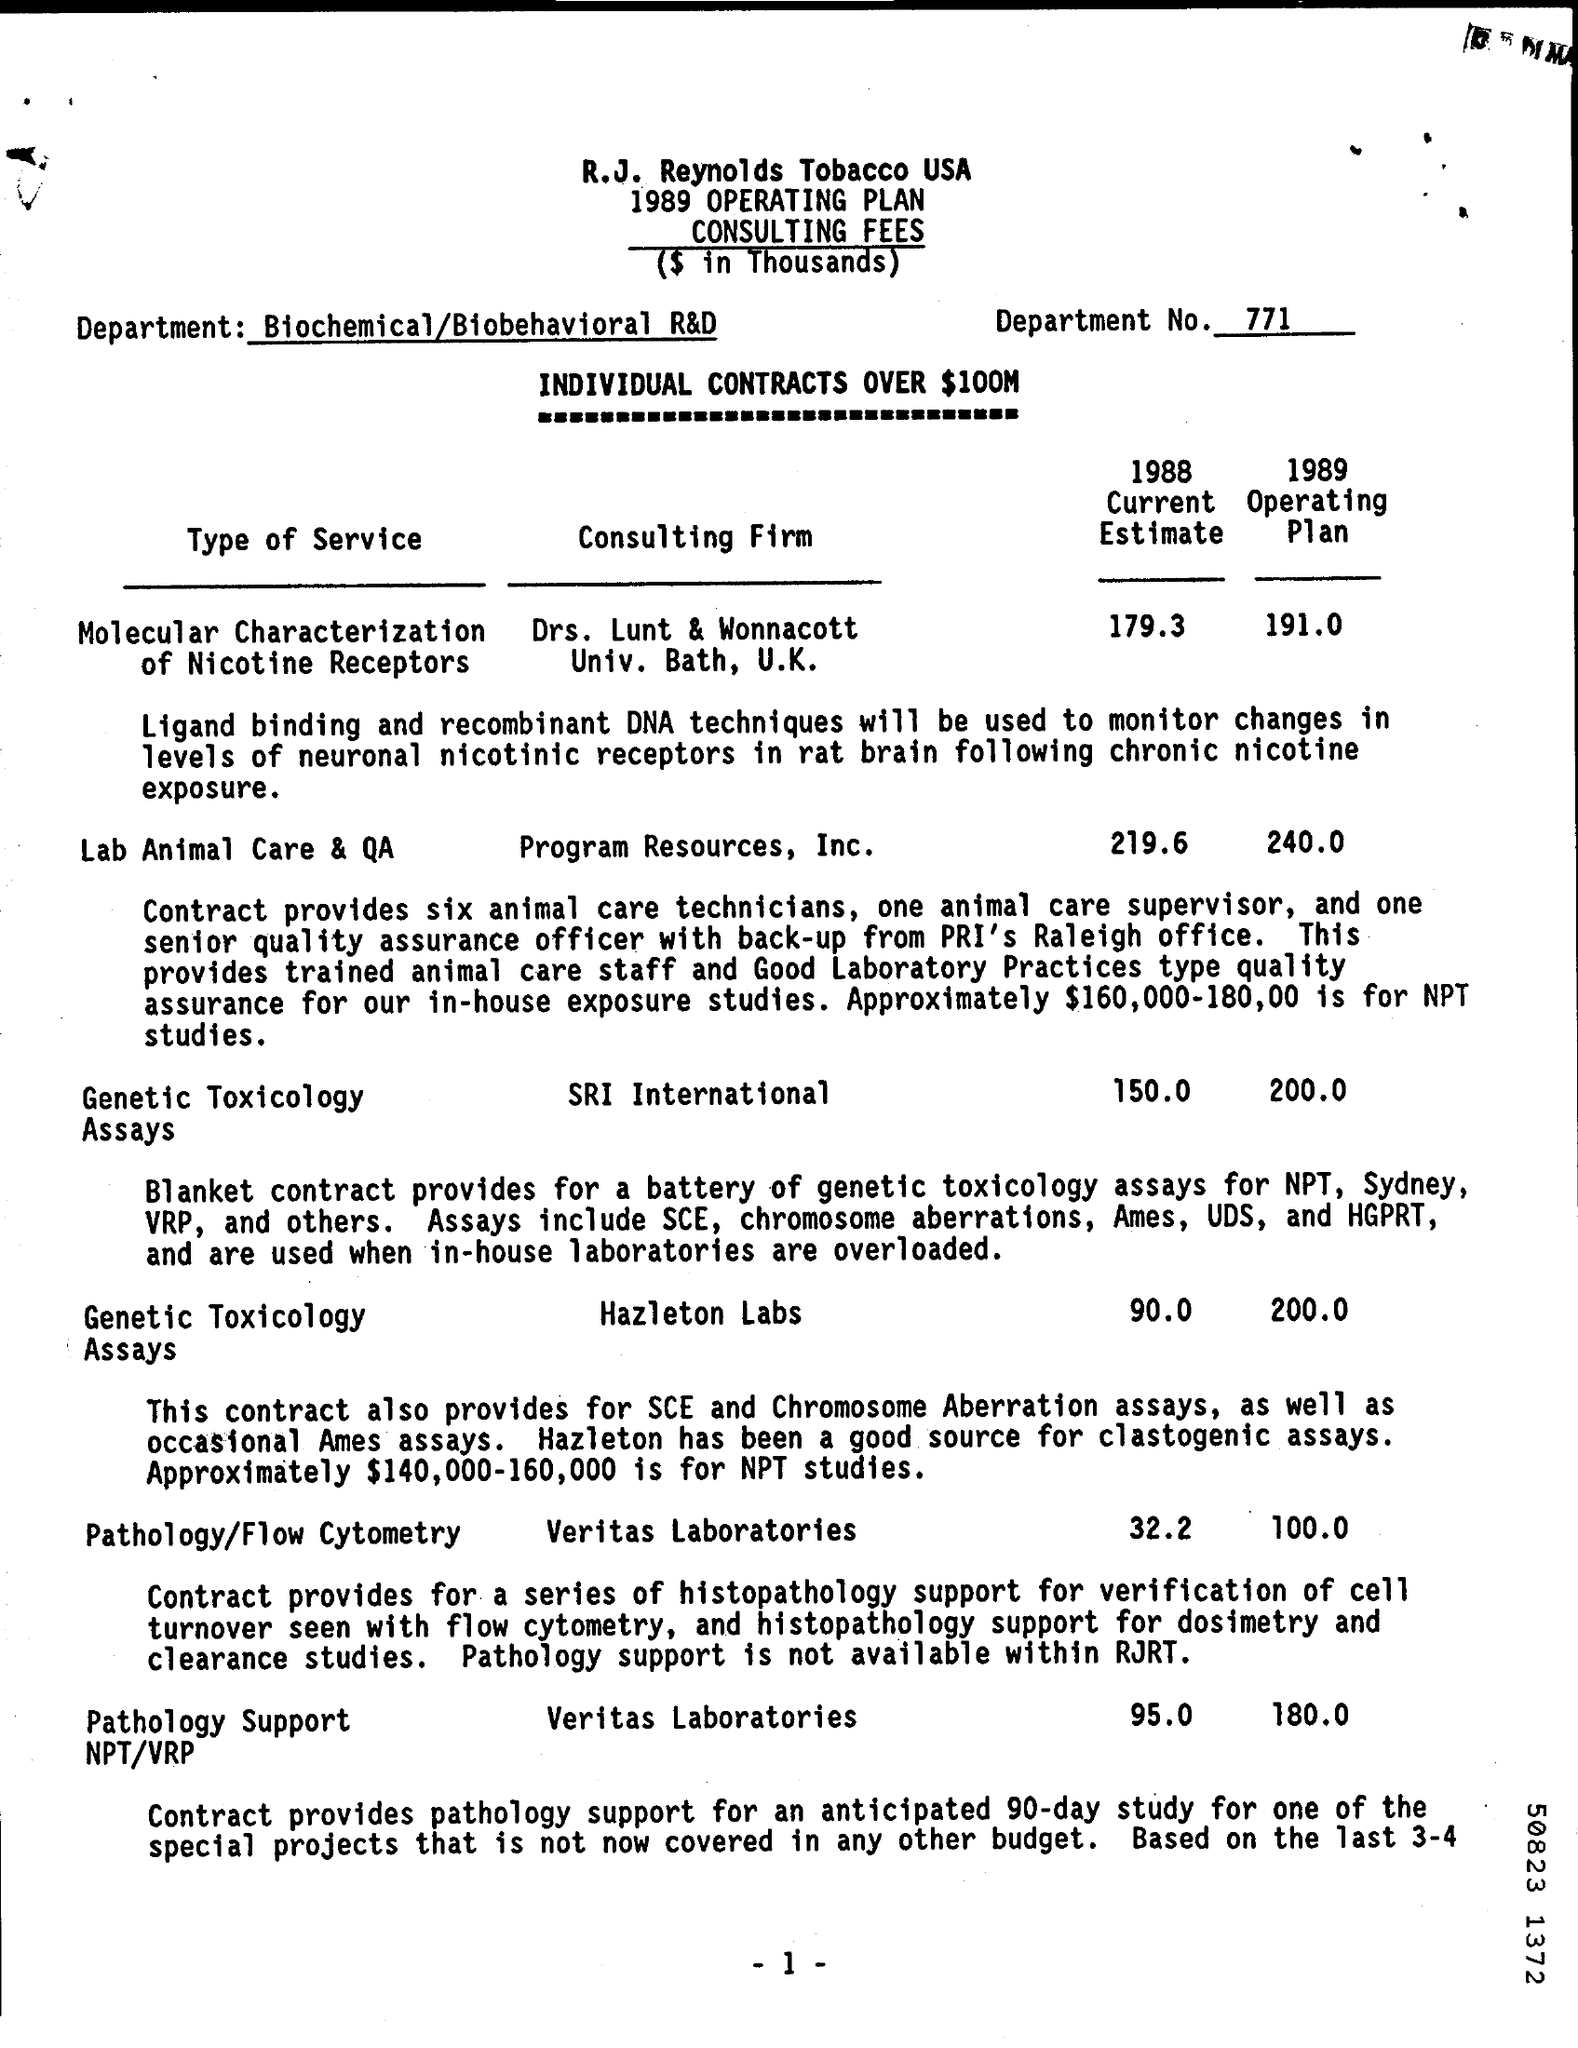Which department is involved?
Offer a very short reply. Biochemical/Biobehavioral R&D. What is the department no.?
Your answer should be very brief. 771. Which is the consulting firm of Genetic Toxicology Assays?
Your answer should be compact. SRI International. What is the 1988 Current Estimate of Program Resources, Inc.?
Offer a very short reply. 219.6. 